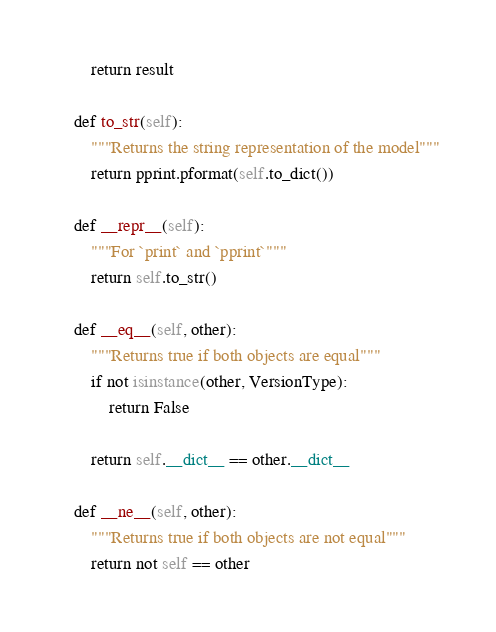Convert code to text. <code><loc_0><loc_0><loc_500><loc_500><_Python_>        return result

    def to_str(self):
        """Returns the string representation of the model"""
        return pprint.pformat(self.to_dict())

    def __repr__(self):
        """For `print` and `pprint`"""
        return self.to_str()

    def __eq__(self, other):
        """Returns true if both objects are equal"""
        if not isinstance(other, VersionType):
            return False

        return self.__dict__ == other.__dict__

    def __ne__(self, other):
        """Returns true if both objects are not equal"""
        return not self == other
</code> 